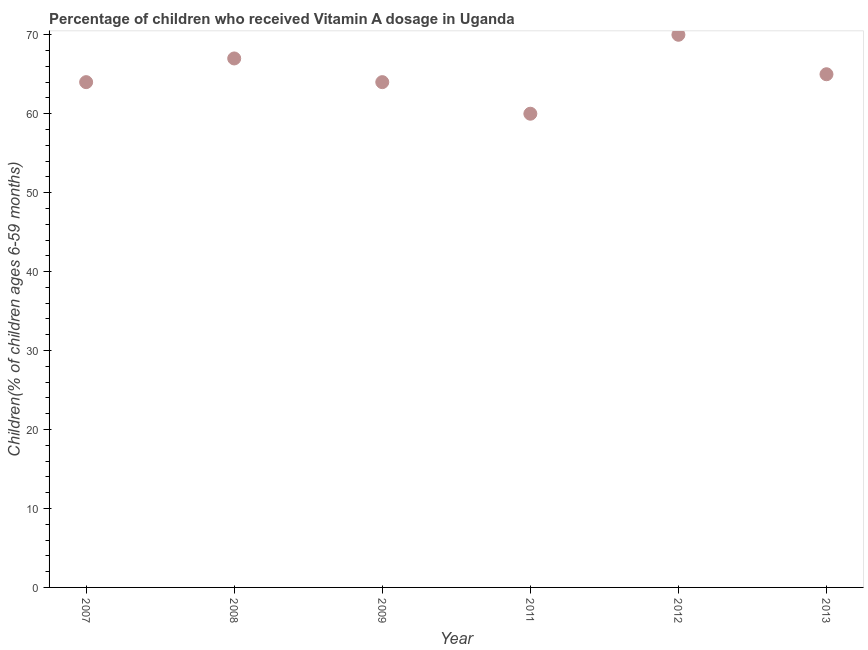What is the vitamin a supplementation coverage rate in 2009?
Your answer should be compact. 64. Across all years, what is the maximum vitamin a supplementation coverage rate?
Offer a terse response. 70. Across all years, what is the minimum vitamin a supplementation coverage rate?
Provide a short and direct response. 60. In which year was the vitamin a supplementation coverage rate maximum?
Your answer should be very brief. 2012. In which year was the vitamin a supplementation coverage rate minimum?
Provide a short and direct response. 2011. What is the sum of the vitamin a supplementation coverage rate?
Your response must be concise. 390. What is the difference between the vitamin a supplementation coverage rate in 2009 and 2013?
Give a very brief answer. -1. What is the median vitamin a supplementation coverage rate?
Offer a terse response. 64.5. Do a majority of the years between 2008 and 2012 (inclusive) have vitamin a supplementation coverage rate greater than 32 %?
Provide a succinct answer. Yes. What is the ratio of the vitamin a supplementation coverage rate in 2007 to that in 2008?
Offer a very short reply. 0.96. Is the sum of the vitamin a supplementation coverage rate in 2009 and 2011 greater than the maximum vitamin a supplementation coverage rate across all years?
Provide a short and direct response. Yes. What is the difference between the highest and the lowest vitamin a supplementation coverage rate?
Ensure brevity in your answer.  10. In how many years, is the vitamin a supplementation coverage rate greater than the average vitamin a supplementation coverage rate taken over all years?
Offer a very short reply. 2. What is the difference between two consecutive major ticks on the Y-axis?
Make the answer very short. 10. Are the values on the major ticks of Y-axis written in scientific E-notation?
Provide a short and direct response. No. Does the graph contain any zero values?
Your answer should be very brief. No. What is the title of the graph?
Make the answer very short. Percentage of children who received Vitamin A dosage in Uganda. What is the label or title of the Y-axis?
Offer a terse response. Children(% of children ages 6-59 months). What is the Children(% of children ages 6-59 months) in 2013?
Your response must be concise. 65. What is the difference between the Children(% of children ages 6-59 months) in 2007 and 2013?
Offer a very short reply. -1. What is the difference between the Children(% of children ages 6-59 months) in 2008 and 2009?
Your answer should be compact. 3. What is the difference between the Children(% of children ages 6-59 months) in 2008 and 2011?
Provide a short and direct response. 7. What is the difference between the Children(% of children ages 6-59 months) in 2008 and 2012?
Give a very brief answer. -3. What is the difference between the Children(% of children ages 6-59 months) in 2008 and 2013?
Your answer should be very brief. 2. What is the difference between the Children(% of children ages 6-59 months) in 2009 and 2013?
Your answer should be very brief. -1. What is the difference between the Children(% of children ages 6-59 months) in 2011 and 2012?
Your response must be concise. -10. What is the difference between the Children(% of children ages 6-59 months) in 2012 and 2013?
Provide a short and direct response. 5. What is the ratio of the Children(% of children ages 6-59 months) in 2007 to that in 2008?
Provide a short and direct response. 0.95. What is the ratio of the Children(% of children ages 6-59 months) in 2007 to that in 2011?
Your answer should be very brief. 1.07. What is the ratio of the Children(% of children ages 6-59 months) in 2007 to that in 2012?
Your response must be concise. 0.91. What is the ratio of the Children(% of children ages 6-59 months) in 2007 to that in 2013?
Offer a very short reply. 0.98. What is the ratio of the Children(% of children ages 6-59 months) in 2008 to that in 2009?
Give a very brief answer. 1.05. What is the ratio of the Children(% of children ages 6-59 months) in 2008 to that in 2011?
Offer a terse response. 1.12. What is the ratio of the Children(% of children ages 6-59 months) in 2008 to that in 2012?
Ensure brevity in your answer.  0.96. What is the ratio of the Children(% of children ages 6-59 months) in 2008 to that in 2013?
Keep it short and to the point. 1.03. What is the ratio of the Children(% of children ages 6-59 months) in 2009 to that in 2011?
Offer a terse response. 1.07. What is the ratio of the Children(% of children ages 6-59 months) in 2009 to that in 2012?
Your response must be concise. 0.91. What is the ratio of the Children(% of children ages 6-59 months) in 2009 to that in 2013?
Offer a terse response. 0.98. What is the ratio of the Children(% of children ages 6-59 months) in 2011 to that in 2012?
Your response must be concise. 0.86. What is the ratio of the Children(% of children ages 6-59 months) in 2011 to that in 2013?
Make the answer very short. 0.92. What is the ratio of the Children(% of children ages 6-59 months) in 2012 to that in 2013?
Your answer should be compact. 1.08. 